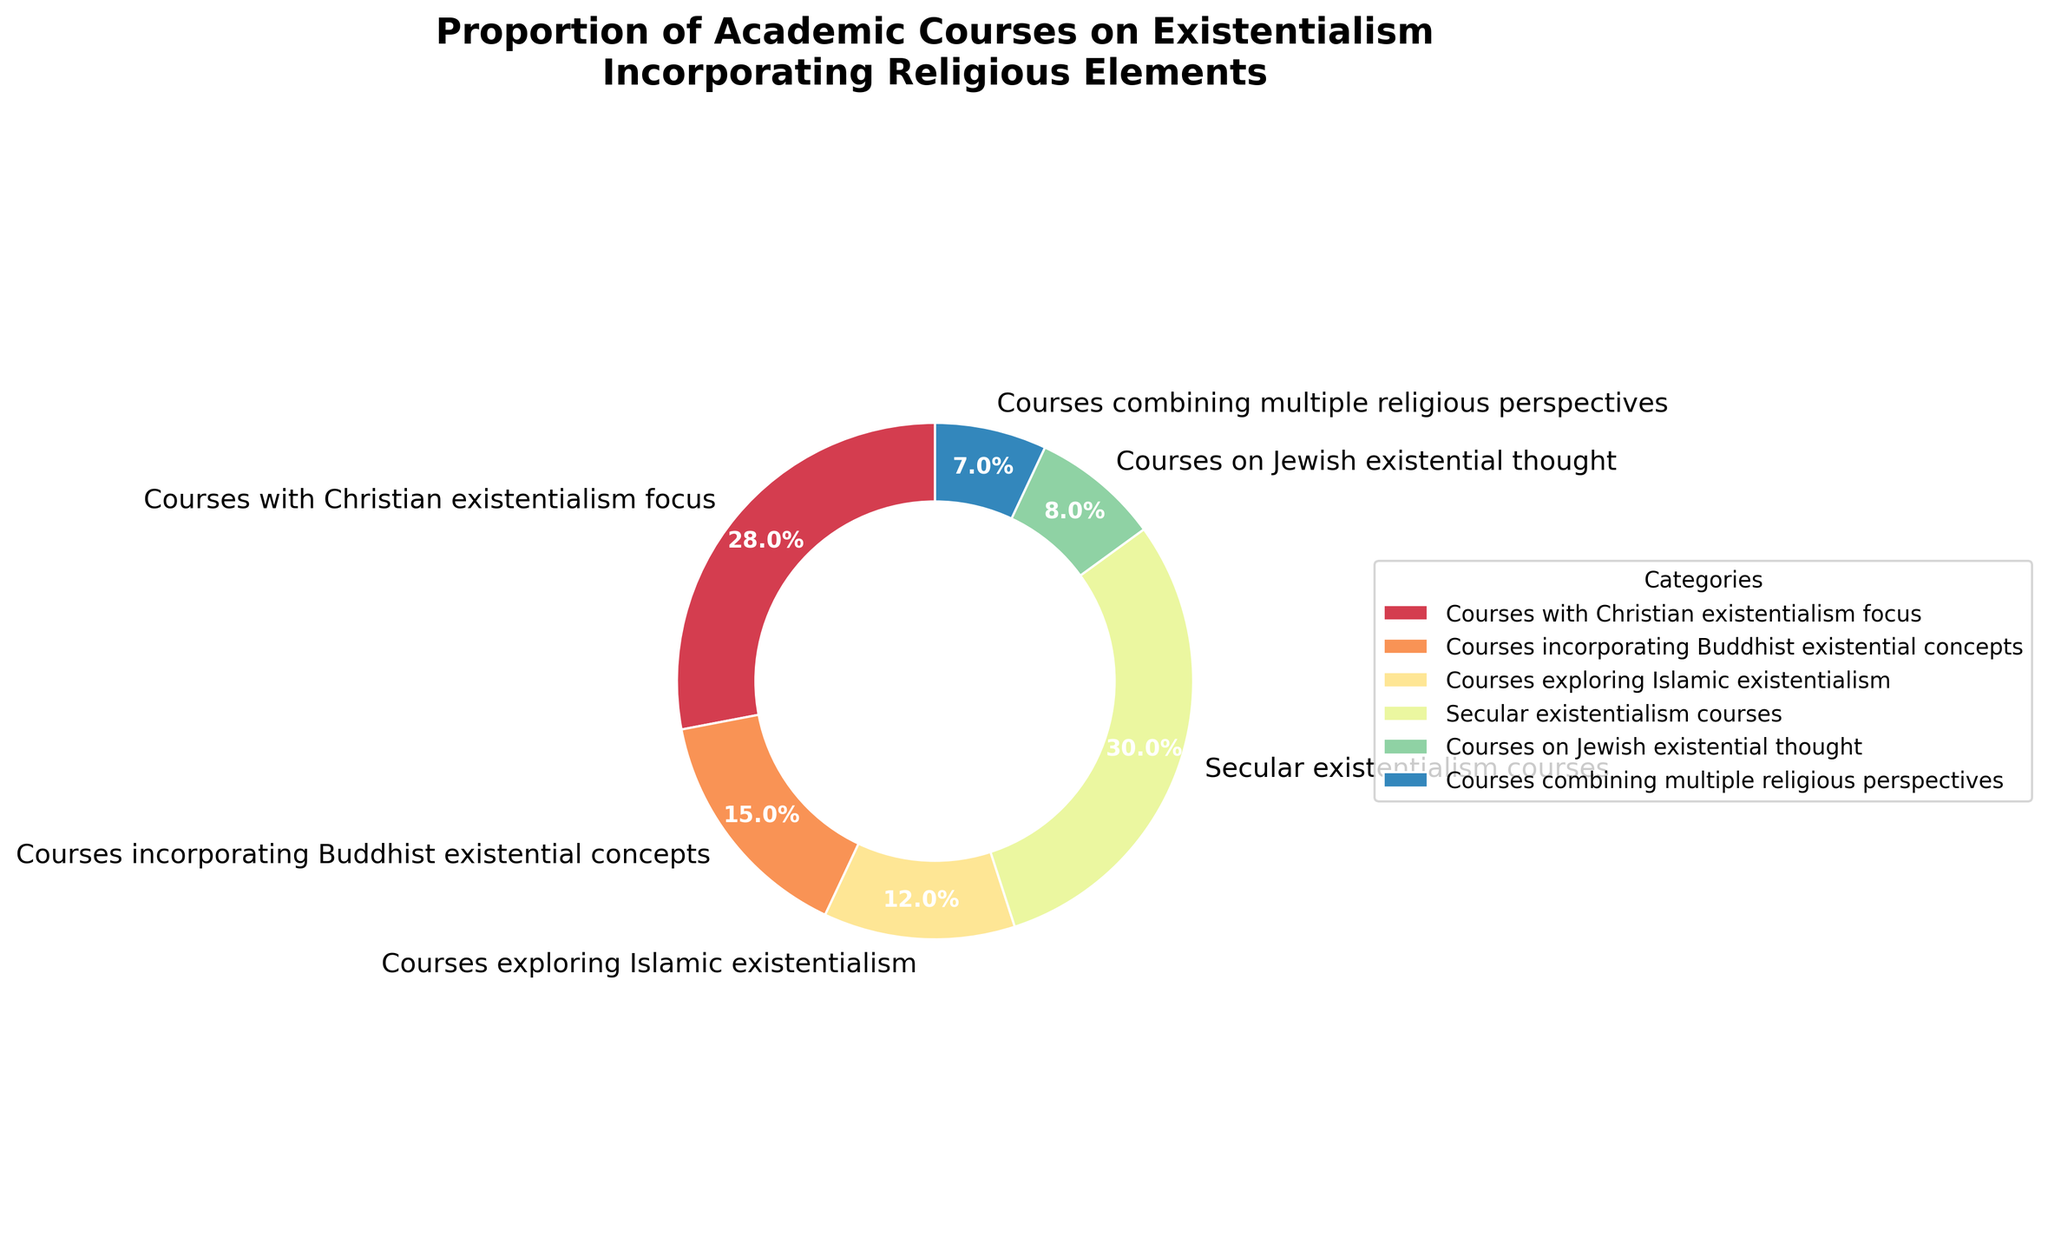What percentage of courses combine multiple religious perspectives? According to the pie chart, there is a category labeled "Courses combining multiple religious perspectives". Refer to its corresponding percentage.
Answer: 7% Which category has the highest percentage of courses? Look at the sectors of the pie chart and identify the one with the largest size. The label and percentage will indicate the category.
Answer: Secular existentialism courses How does the percentage of courses focusing on Christian existentialism compare to those incorporating Buddhist existential concepts? Identify the percentages of "Courses with Christian existentialism focus" and "Courses incorporating Buddhist existential concepts", then compare the two.
Answer: 28% vs 15% What is the combined percentage of courses that have a religious element? Sum the percentages of all categories except "Secular existentialism courses". The relevant categories are "Courses with Christian existentialism focus," "Courses incorporating Buddhist existential concepts," "Courses exploring Islamic existentialism," "Courses on Jewish existential thought," and "Courses combining multiple religious perspectives."
Answer: 28 + 15 + 12 + 8 + 7 = 70% Which religious existential courses have the smallest representation? Look for the smallest percentage among the categories connected to religions. From the slices of the pie, this can be identified.
Answer: Courses on Jewish existential thought Are there more courses incorporating Islamic existentialism or Buddhist existential concepts? Compare the percentages of "Courses exploring Islamic existentialism" and "Courses incorporating Buddhist existential concepts."
Answer: Buddhist existential concepts What fraction of the total courses does secular existentialism represent? Convert the percentage of "Secular existentialism courses" into a fraction relative to the total 100%.
Answer: 30/100 or 3/10 What is the difference in percentage between courses with Christian existentialism focus and courses on Jewish existential thought? Subtract the percentage of "Courses on Jewish existential thought" from "Courses with Christian existentialism focus."
Answer: 28% - 8% = 20% How many times more prevalent are Christian existentialism courses compared to courses combining multiple religious perspectives? Divide the percentage of "Courses with Christian existentialism focus" by the percentage of "Courses combining multiple religious perspectives."
Answer: 28% ÷ 7% = 4 What is the average percentage of courses incorporating either Buddhist or Islamic existential concepts? Calculate the average by adding the percentages of "Courses incorporating Buddhist existential concepts" and "Courses exploring Islamic existentialism", then divide by 2.
Answer: (15% + 12%) ÷ 2 = 13.5% 